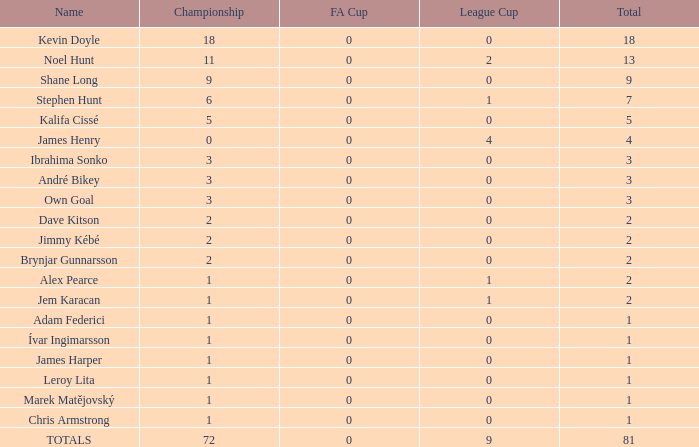What is the total championships of James Henry that has a league cup more than 1? 0.0. 